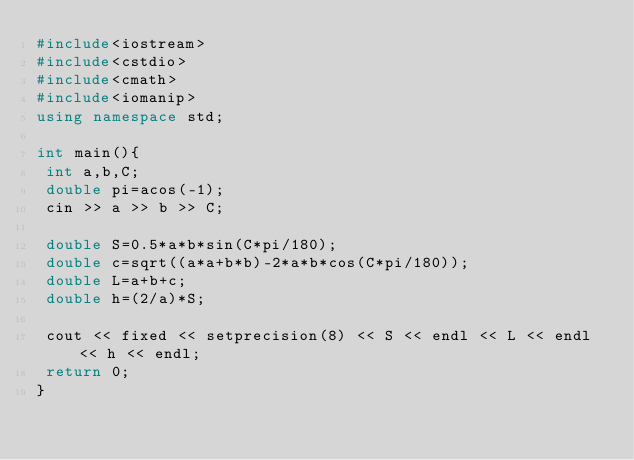<code> <loc_0><loc_0><loc_500><loc_500><_C++_>#include<iostream>
#include<cstdio>
#include<cmath>
#include<iomanip>
using namespace std;

int main(){
 int a,b,C;
 double pi=acos(-1);
 cin >> a >> b >> C;

 double S=0.5*a*b*sin(C*pi/180);
 double c=sqrt((a*a+b*b)-2*a*b*cos(C*pi/180));
 double L=a+b+c;
 double h=(2/a)*S;

 cout << fixed << setprecision(8) << S << endl << L << endl << h << endl;
 return 0;
}</code> 